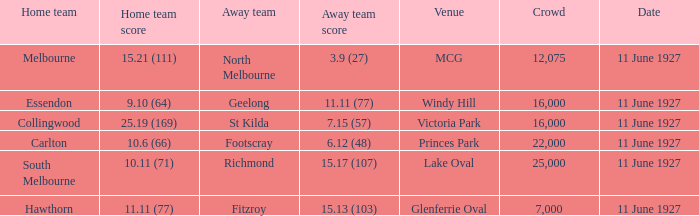How many people were present in a total of every crowd at the MCG venue? 12075.0. 